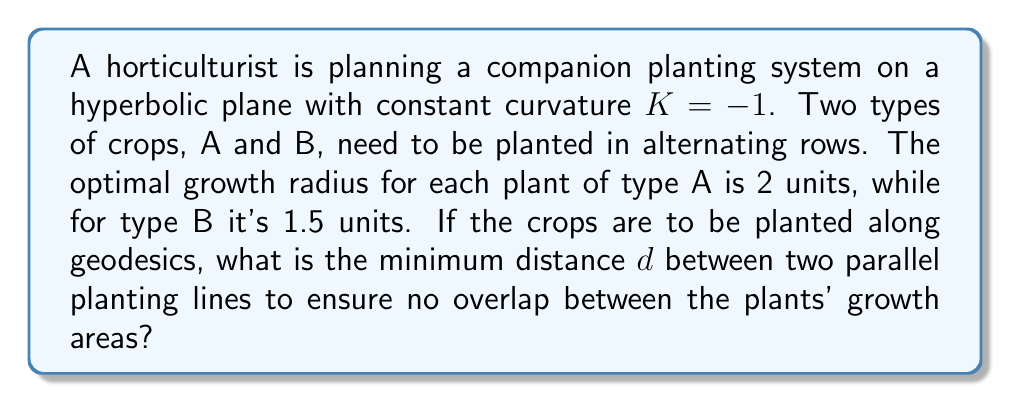Show me your answer to this math problem. To solve this problem, we need to consider the geometry of circles on a hyperbolic plane and use the concept of hyperbolic distance.

Step 1: Determine the radius of the larger circle
The larger circle is formed by plants of type A, with a radius of 2 units.

Step 2: Calculate the area of the larger circle
In hyperbolic geometry with curvature $K = -1$, the area of a circle with radius $r$ is given by:

$$A = 4\pi \sinh^2(\frac{r}{2})$$

For the larger circle:
$$A_A = 4\pi \sinh^2(1) \approx 27.31$$

Step 3: Find the hyperbolic radius $R$ of a circle with the same area on the Euclidean plane
$$\pi R^2 = 4\pi \sinh^2(1)$$
$$R^2 = 4 \sinh^2(1)$$
$$R = 2\sinh(1) \approx 2.31$$

Step 4: Determine the minimum distance between parallel lines
The minimum distance $d$ should be twice the hyperbolic radius $R$:

$$d = 2R = 4\sinh(1)$$

This ensures that the circles representing the growth areas of plants on adjacent lines just touch without overlapping.

Step 5: Verify that this distance also works for the smaller plants (type B)
The hyperbolic radius for type B plants (with growth radius 1.5 units) is:

$$R_B = 2\sinh(0.75) \approx 1.72$$

Since $4\sinh(1) > 2(2\sinh(0.75))$, the calculated distance $d$ is sufficient for both plant types.
Answer: $d = 4\sinh(1) \approx 4.62$ units 